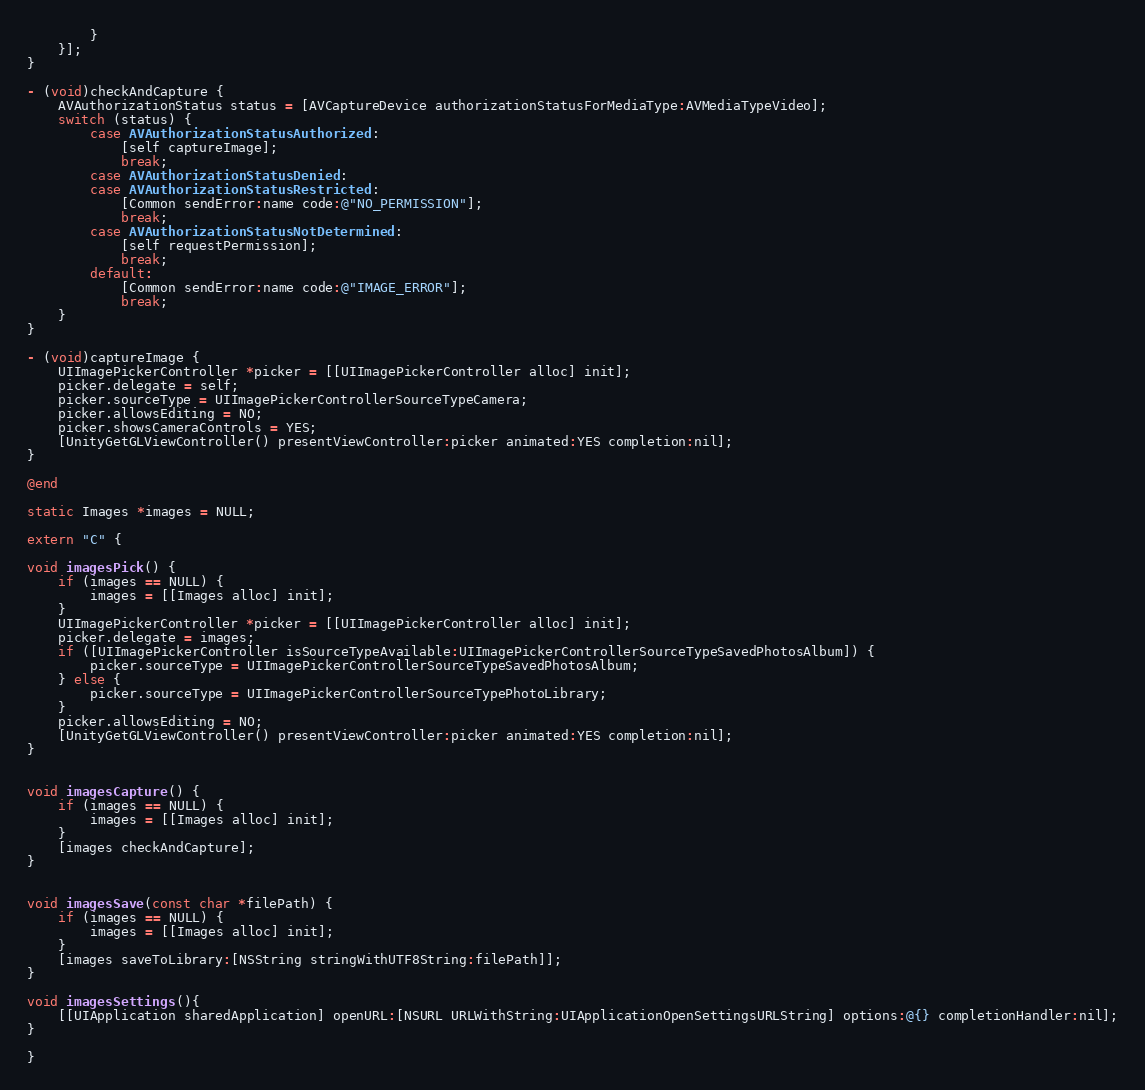<code> <loc_0><loc_0><loc_500><loc_500><_ObjectiveC_>        }
    }];
}

- (void)checkAndCapture {
    AVAuthorizationStatus status = [AVCaptureDevice authorizationStatusForMediaType:AVMediaTypeVideo];
    switch (status) {
        case AVAuthorizationStatusAuthorized:
            [self captureImage];
            break;
        case AVAuthorizationStatusDenied:
        case AVAuthorizationStatusRestricted:
            [Common sendError:name code:@"NO_PERMISSION"];
            break;
        case AVAuthorizationStatusNotDetermined:
            [self requestPermission];
            break;
        default:
            [Common sendError:name code:@"IMAGE_ERROR"];
            break;
    }
}

- (void)captureImage {
    UIImagePickerController *picker = [[UIImagePickerController alloc] init];
    picker.delegate = self;
    picker.sourceType = UIImagePickerControllerSourceTypeCamera;
    picker.allowsEditing = NO;
    picker.showsCameraControls = YES;
    [UnityGetGLViewController() presentViewController:picker animated:YES completion:nil];
}

@end

static Images *images = NULL;

extern "C" {

void imagesPick() {
    if (images == NULL) {
        images = [[Images alloc] init];
    }
    UIImagePickerController *picker = [[UIImagePickerController alloc] init];
    picker.delegate = images;
    if ([UIImagePickerController isSourceTypeAvailable:UIImagePickerControllerSourceTypeSavedPhotosAlbum]) {
        picker.sourceType = UIImagePickerControllerSourceTypeSavedPhotosAlbum;
    } else {
        picker.sourceType = UIImagePickerControllerSourceTypePhotoLibrary;
    }
    picker.allowsEditing = NO;
    [UnityGetGLViewController() presentViewController:picker animated:YES completion:nil];
}


void imagesCapture() {
    if (images == NULL) {
        images = [[Images alloc] init];
    }
    [images checkAndCapture];
}


void imagesSave(const char *filePath) {
    if (images == NULL) {
        images = [[Images alloc] init];
    }
    [images saveToLibrary:[NSString stringWithUTF8String:filePath]];
}

void imagesSettings(){
    [[UIApplication sharedApplication] openURL:[NSURL URLWithString:UIApplicationOpenSettingsURLString] options:@{} completionHandler:nil];
}

}
</code> 